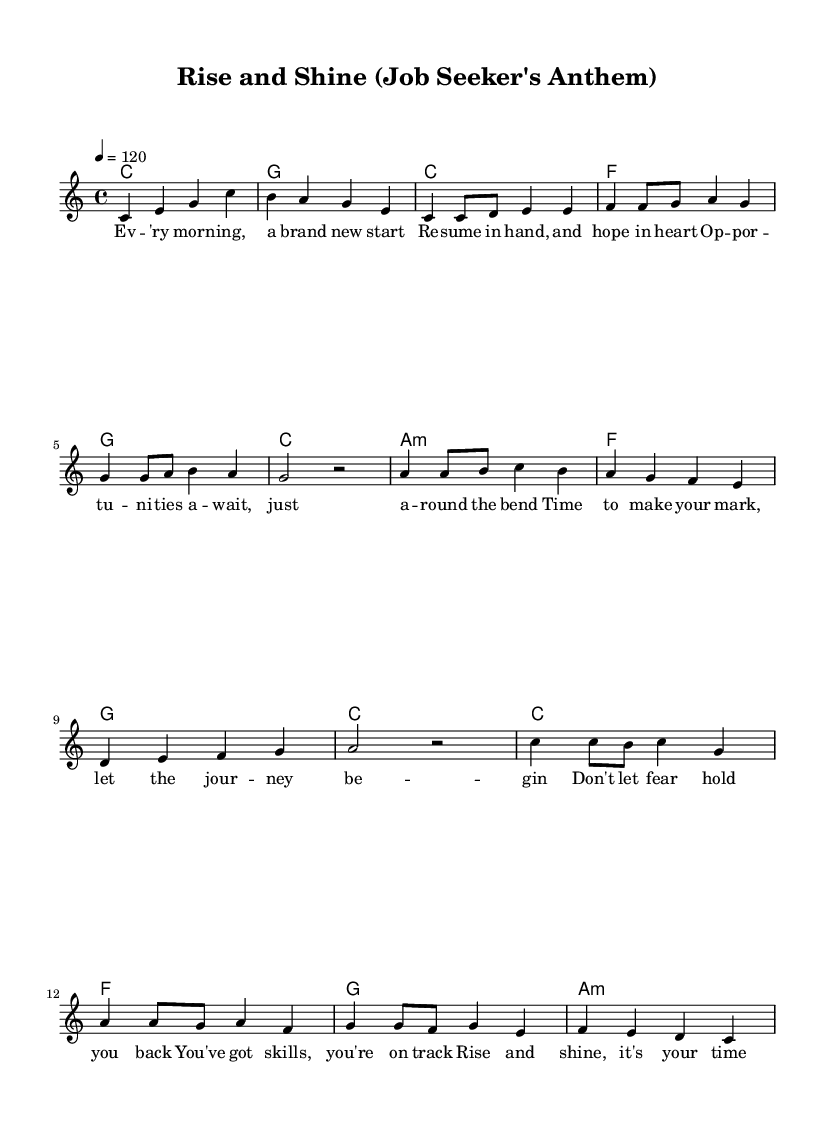What is the key signature of this music? The key signature is C major, which has no sharps or flats.
Answer: C major What is the time signature of this piece? The time signature is indicated as 4/4, meaning there are four beats per measure.
Answer: 4/4 What is the tempo marking for this composition? The tempo marking shows that the piece should be played at a quarter note equals 120 beats per minute.
Answer: 120 How many measures are in the chorus section? The chorus is structured in four measures, which can be counted easily from the notation.
Answer: 4 What chord follows the pre-chorus? The pre-chorus ends with a G chord, which leads into the chorus.
Answer: G In which section do the lyrics mention opportunities? The lyrics mentioning opportunities are found in the verse section, where they describe the beginning of the job hunt.
Answer: Verse What is the main theme of the song? The main theme conveys motivation and encouragement for job seekers during their journey, emphasizing positivity and perseverance.
Answer: Motivation 